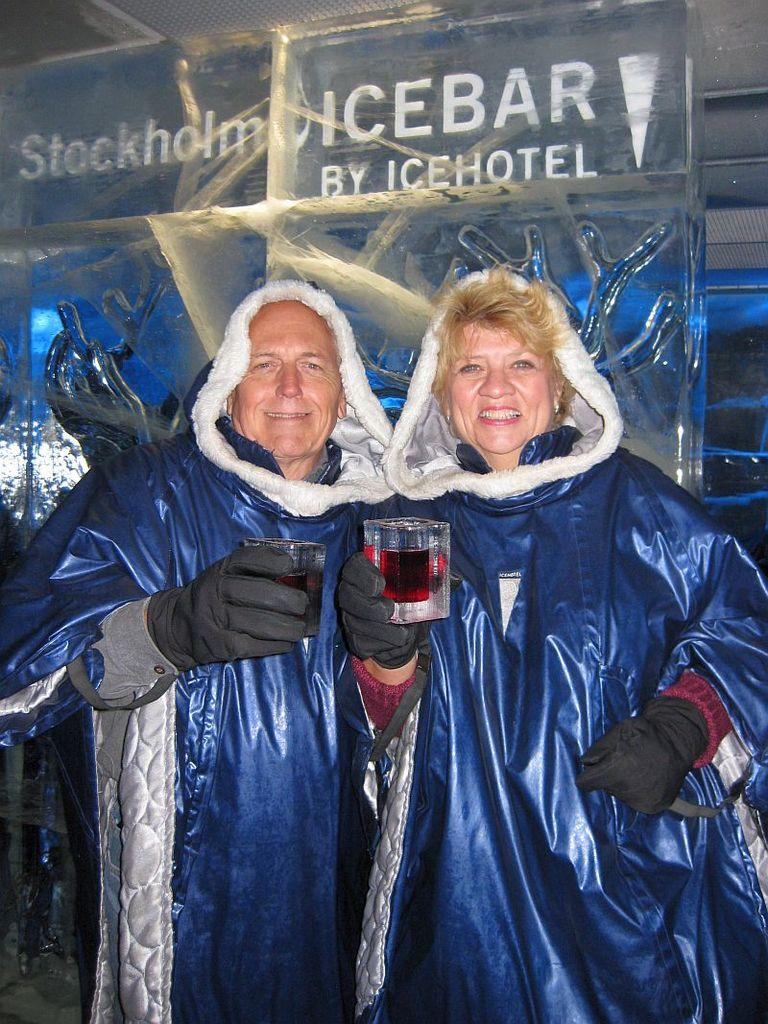<image>
Give a short and clear explanation of the subsequent image. The couple is in the city of Stockholm at the Icebar 